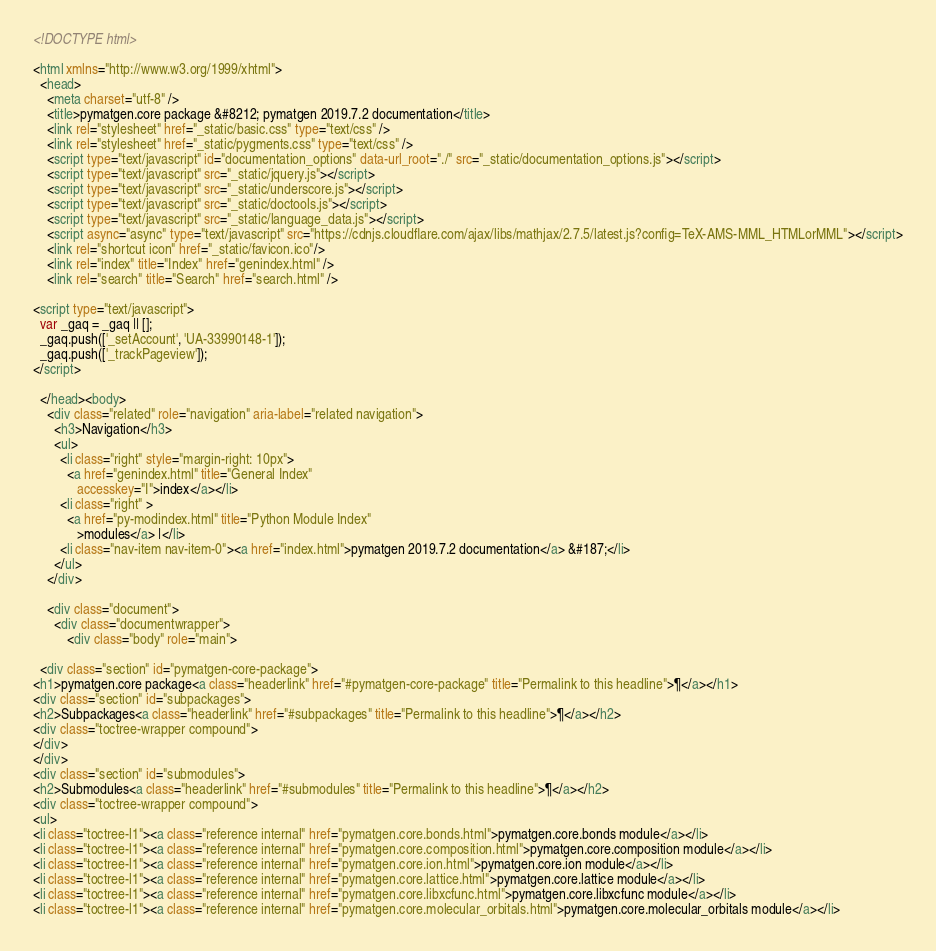Convert code to text. <code><loc_0><loc_0><loc_500><loc_500><_HTML_>
<!DOCTYPE html>

<html xmlns="http://www.w3.org/1999/xhtml">
  <head>
    <meta charset="utf-8" />
    <title>pymatgen.core package &#8212; pymatgen 2019.7.2 documentation</title>
    <link rel="stylesheet" href="_static/basic.css" type="text/css" />
    <link rel="stylesheet" href="_static/pygments.css" type="text/css" />
    <script type="text/javascript" id="documentation_options" data-url_root="./" src="_static/documentation_options.js"></script>
    <script type="text/javascript" src="_static/jquery.js"></script>
    <script type="text/javascript" src="_static/underscore.js"></script>
    <script type="text/javascript" src="_static/doctools.js"></script>
    <script type="text/javascript" src="_static/language_data.js"></script>
    <script async="async" type="text/javascript" src="https://cdnjs.cloudflare.com/ajax/libs/mathjax/2.7.5/latest.js?config=TeX-AMS-MML_HTMLorMML"></script>
    <link rel="shortcut icon" href="_static/favicon.ico"/>
    <link rel="index" title="Index" href="genindex.html" />
    <link rel="search" title="Search" href="search.html" />
 
<script type="text/javascript">
  var _gaq = _gaq || [];
  _gaq.push(['_setAccount', 'UA-33990148-1']);
  _gaq.push(['_trackPageview']);
</script>

  </head><body>
    <div class="related" role="navigation" aria-label="related navigation">
      <h3>Navigation</h3>
      <ul>
        <li class="right" style="margin-right: 10px">
          <a href="genindex.html" title="General Index"
             accesskey="I">index</a></li>
        <li class="right" >
          <a href="py-modindex.html" title="Python Module Index"
             >modules</a> |</li>
        <li class="nav-item nav-item-0"><a href="index.html">pymatgen 2019.7.2 documentation</a> &#187;</li> 
      </ul>
    </div>  

    <div class="document">
      <div class="documentwrapper">
          <div class="body" role="main">
            
  <div class="section" id="pymatgen-core-package">
<h1>pymatgen.core package<a class="headerlink" href="#pymatgen-core-package" title="Permalink to this headline">¶</a></h1>
<div class="section" id="subpackages">
<h2>Subpackages<a class="headerlink" href="#subpackages" title="Permalink to this headline">¶</a></h2>
<div class="toctree-wrapper compound">
</div>
</div>
<div class="section" id="submodules">
<h2>Submodules<a class="headerlink" href="#submodules" title="Permalink to this headline">¶</a></h2>
<div class="toctree-wrapper compound">
<ul>
<li class="toctree-l1"><a class="reference internal" href="pymatgen.core.bonds.html">pymatgen.core.bonds module</a></li>
<li class="toctree-l1"><a class="reference internal" href="pymatgen.core.composition.html">pymatgen.core.composition module</a></li>
<li class="toctree-l1"><a class="reference internal" href="pymatgen.core.ion.html">pymatgen.core.ion module</a></li>
<li class="toctree-l1"><a class="reference internal" href="pymatgen.core.lattice.html">pymatgen.core.lattice module</a></li>
<li class="toctree-l1"><a class="reference internal" href="pymatgen.core.libxcfunc.html">pymatgen.core.libxcfunc module</a></li>
<li class="toctree-l1"><a class="reference internal" href="pymatgen.core.molecular_orbitals.html">pymatgen.core.molecular_orbitals module</a></li></code> 